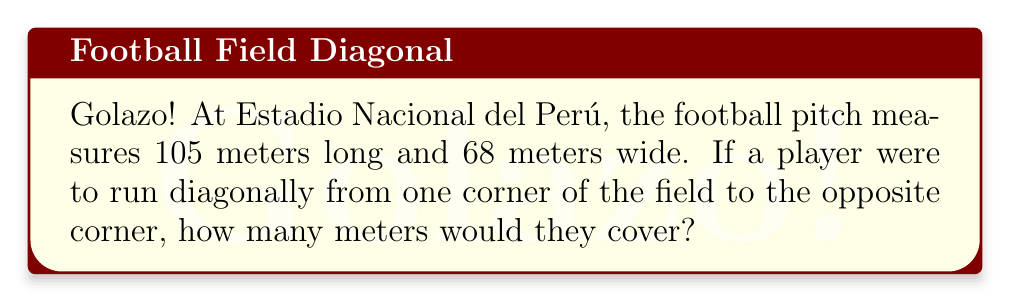Provide a solution to this math problem. Let's tackle this problem step-by-step, amigos!

1) The football pitch forms a rectangle. The diagonal line from one corner to the opposite corner forms the hypotenuse of a right triangle.

2) We can use the Pythagorean theorem to find the length of this diagonal. The theorem states that in a right triangle, $a^2 + b^2 = c^2$, where $c$ is the hypotenuse and $a$ and $b$ are the other two sides.

3) In our case:
   $a = 105$ meters (length of the pitch)
   $b = 68$ meters (width of the pitch)
   Let $c$ be the diagonal we're looking for.

4) Applying the Pythagorean theorem:
   $$c^2 = 105^2 + 68^2$$

5) Let's calculate:
   $$c^2 = 11025 + 4624 = 15649$$

6) To find $c$, we need to take the square root of both sides:
   $$c = \sqrt{15649}$$

7) Using a calculator or computing this value:
   $$c \approx 125.0959$$

8) Rounding to two decimal places for practical purposes:
   $$c \approx 125.10\text{ meters}$$

[asy]
import geometry;

pair A=(0,0), B=(105,0), C=(105,68), D=(0,68);
draw(A--B--C--D--cycle);
draw(A--C,dashed);

label("105 m",B,(0,-2));
label("68 m",C,(2,0));
label("125.10 m",A,SE);

dot("A",A,SW);
dot("C",C,NE);
[/asy]
Answer: 125.10 meters 